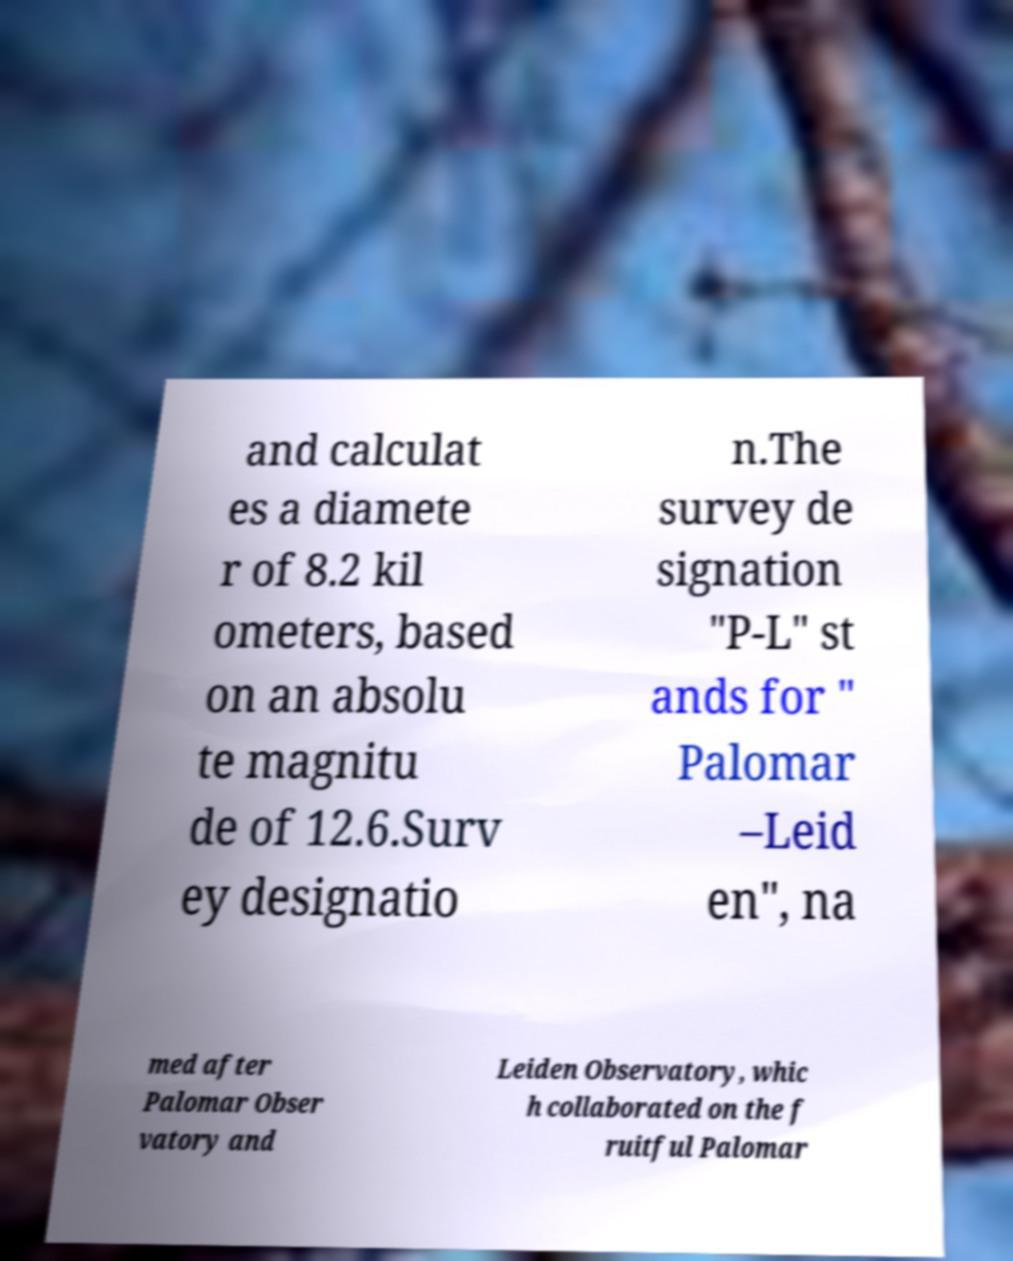Can you read and provide the text displayed in the image?This photo seems to have some interesting text. Can you extract and type it out for me? and calculat es a diamete r of 8.2 kil ometers, based on an absolu te magnitu de of 12.6.Surv ey designatio n.The survey de signation "P-L" st ands for " Palomar –Leid en", na med after Palomar Obser vatory and Leiden Observatory, whic h collaborated on the f ruitful Palomar 